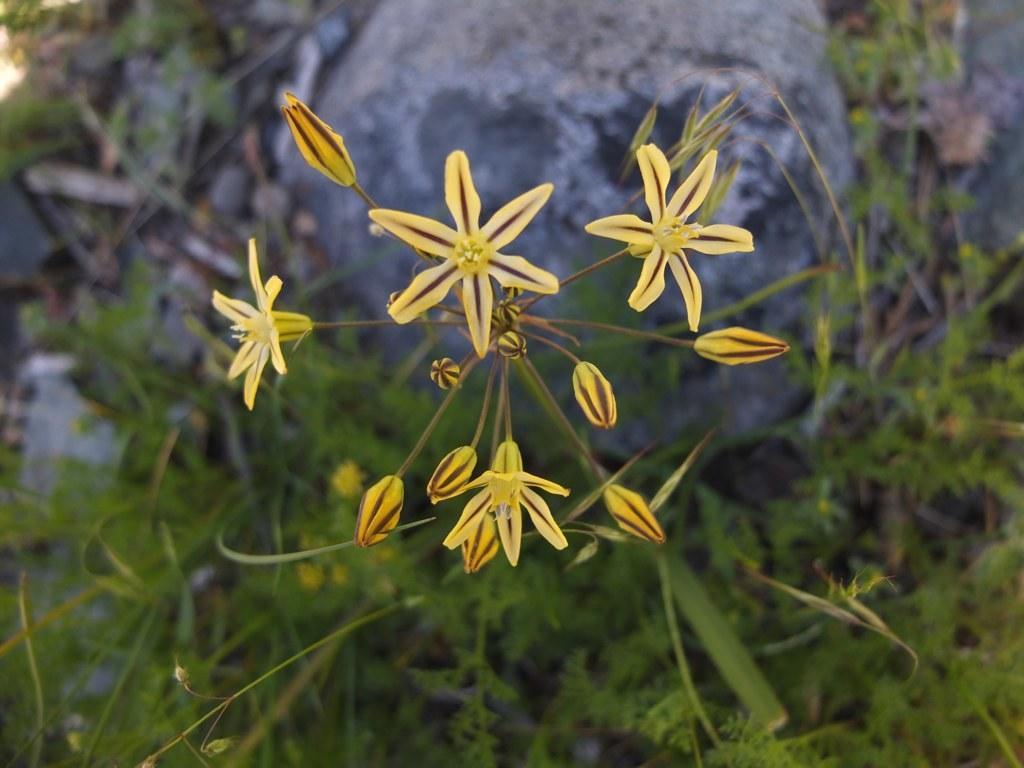Could you give a brief overview of what you see in this image? In this picture I can see flowers, plants and a rock in the background. 